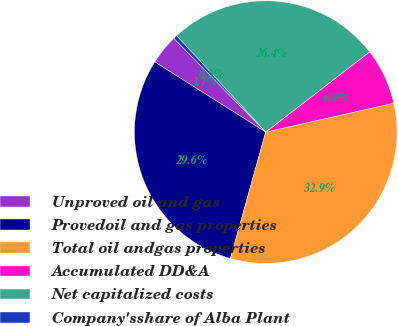Convert chart. <chart><loc_0><loc_0><loc_500><loc_500><pie_chart><fcel>Unproved oil and gas<fcel>Provedoil and gas properties<fcel>Total oil andgas properties<fcel>Accumulated DD&A<fcel>Net capitalized costs<fcel>Company'sshare of Alba Plant<nl><fcel>3.69%<fcel>29.64%<fcel>32.87%<fcel>6.93%<fcel>26.41%<fcel>0.46%<nl></chart> 